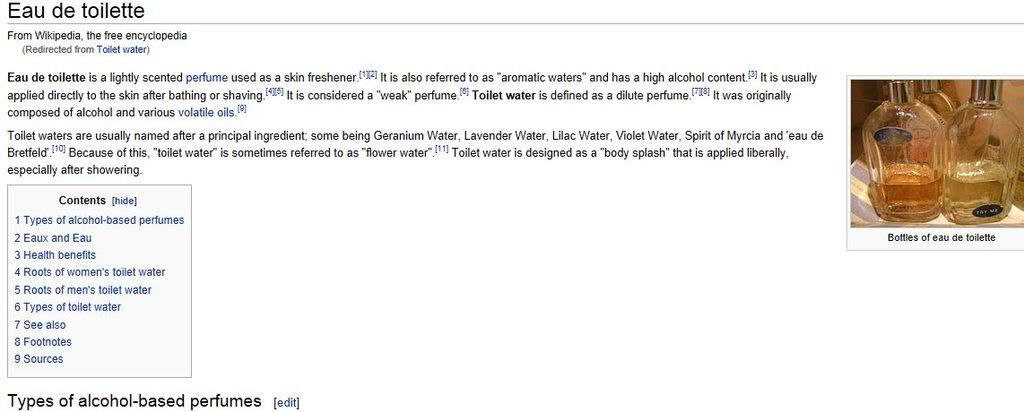<image>
Summarize the visual content of the image. A Wikipedia exerpt about Eau de Toilette is described as a lightly scented perfume. 